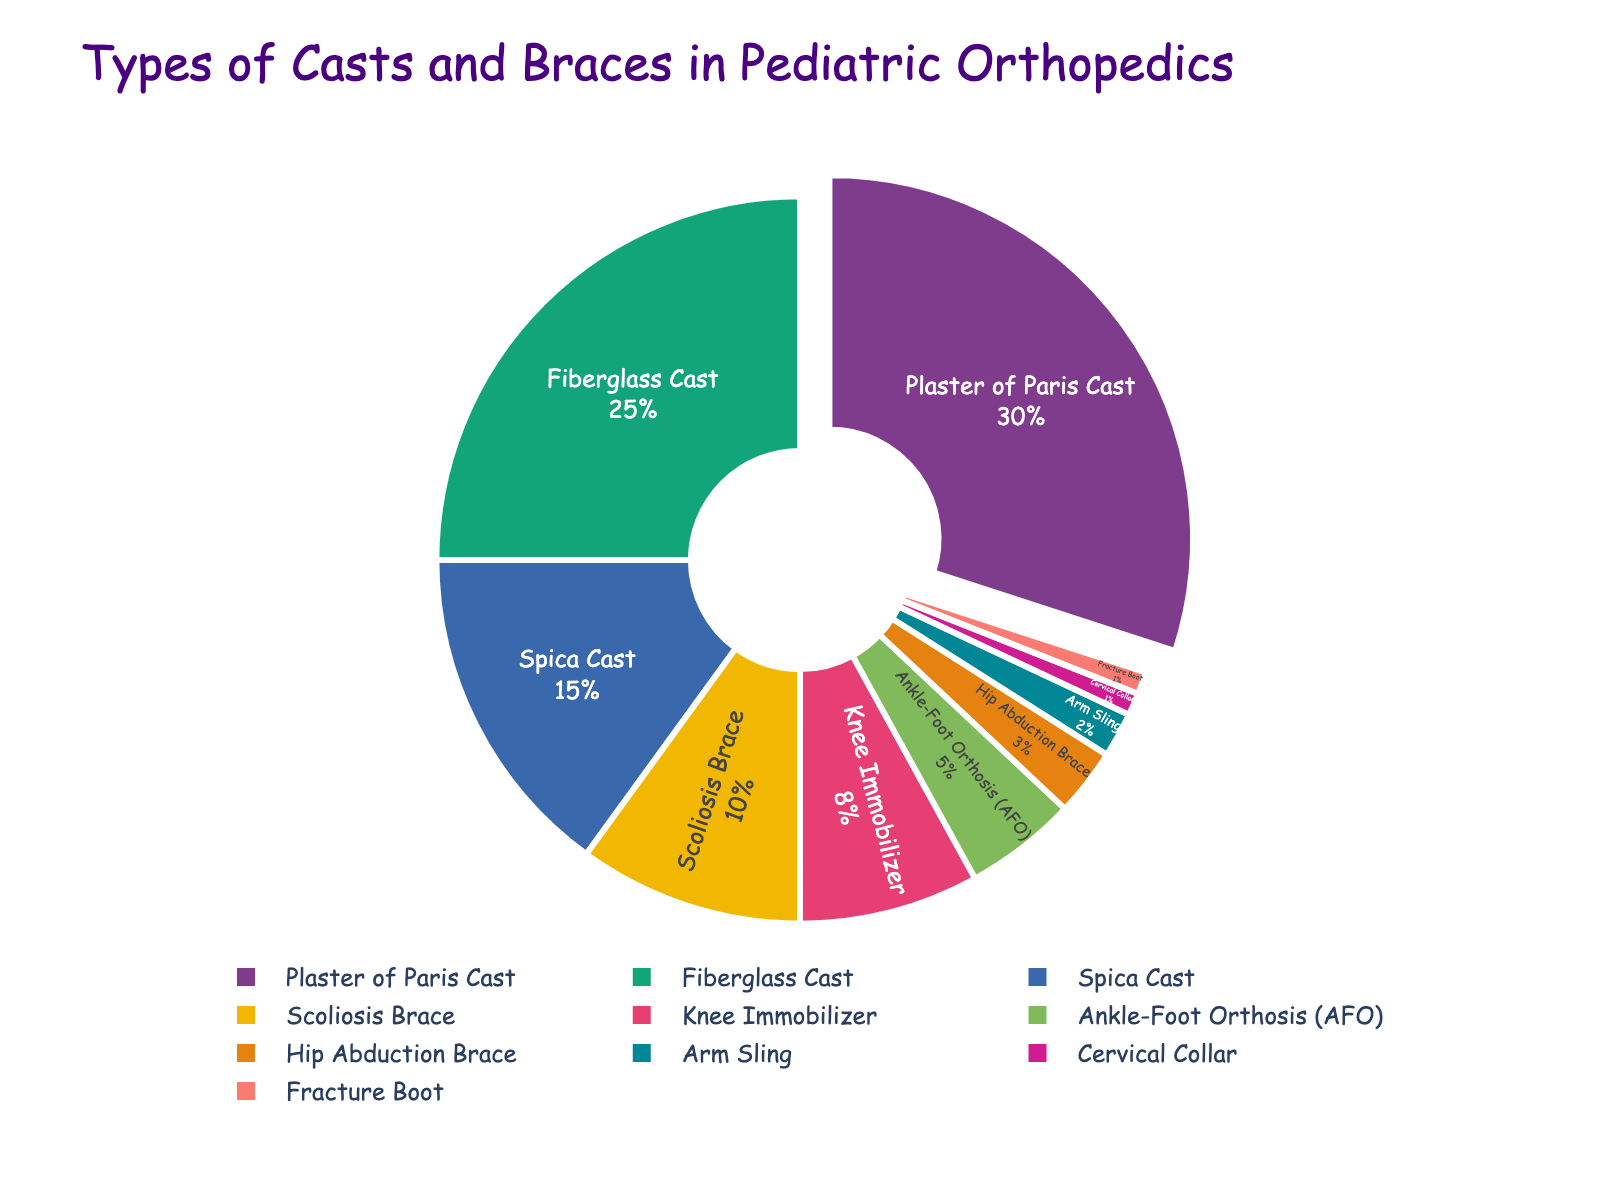Which type of orthopedic support is used the most in pediatric orthopedics? The pie chart shows that the Plaster of Paris Cast has the largest segment, indicating it is used the most.
Answer: Plaster of Paris Cast Which type of cast or brace is used more, the Scoliosis Brace or the Fiberglass Cast? By observing the chart, the segment for the Fiberglass Cast is larger than the one for the Scoliosis Brace.
Answer: Fiberglass Cast What is the combined percentage of use for the Knee Immobilizer and the Ankle-Foot Orthosis (AFO)? The Knee Immobilizer is 8% and the Ankle-Foot Orthosis (AFO) is 5%, so adding them together gives 8% + 5% = 13%.
Answer: 13% How much more is the percentage of the Spica Cast compared to the Hip Abduction Brace? The Spica Cast is at 15% and the Hip Abduction Brace is at 3%. The difference is 15% - 3% = 12%.
Answer: 12% Which has a smaller percentage, the Arm Sling or the Cervical Collar? From the chart, it can be seen that the Arm Sling (2%) has a larger percentage compared to the Cervical Collar (1%).
Answer: Cervical Collar What is the total percentage of the four least used types of orthopedic supports? The four least used types are Hip Abduction Brace (3%), Arm Sling (2%), Cervical Collar (1%), and Fracture Boot (1%). Adding them together, we get 3% + 2% + 1% + 1% = 7%.
Answer: 7% What is the difference in percentage between the Plaster of Paris Cast and the Scoliosis Brace? Plaster of Paris Cast is 30% and Scoliosis Brace is 10%, so the difference is 30% - 10% = 20%.
Answer: 20% What is the combined percentage of use for orthopedic supports that have more than 10% usage? The relevant supports are Plaster of Paris Cast (30%), Fiberglass Cast (25%), and Spica Cast (15%). Their combined percentage is 30% + 25% + 15% = 70%.
Answer: 70% Which has a larger percentage, the Fiberglass Cast or all the supports used less than 5% combined? The Fiberglass Cast is 25%. Supports used less than 5% are Ankle-Foot Orthosis (5%), Hip Abduction Brace (3%), Arm Sling (2%), Cervical Collar (1%), and Fracture Boot (1%), totaling 5% + 3% + 2% + 1% + 1% = 12%. Thus, the Fiberglass Cast has a larger percentage.
Answer: Fiberglass Cast 